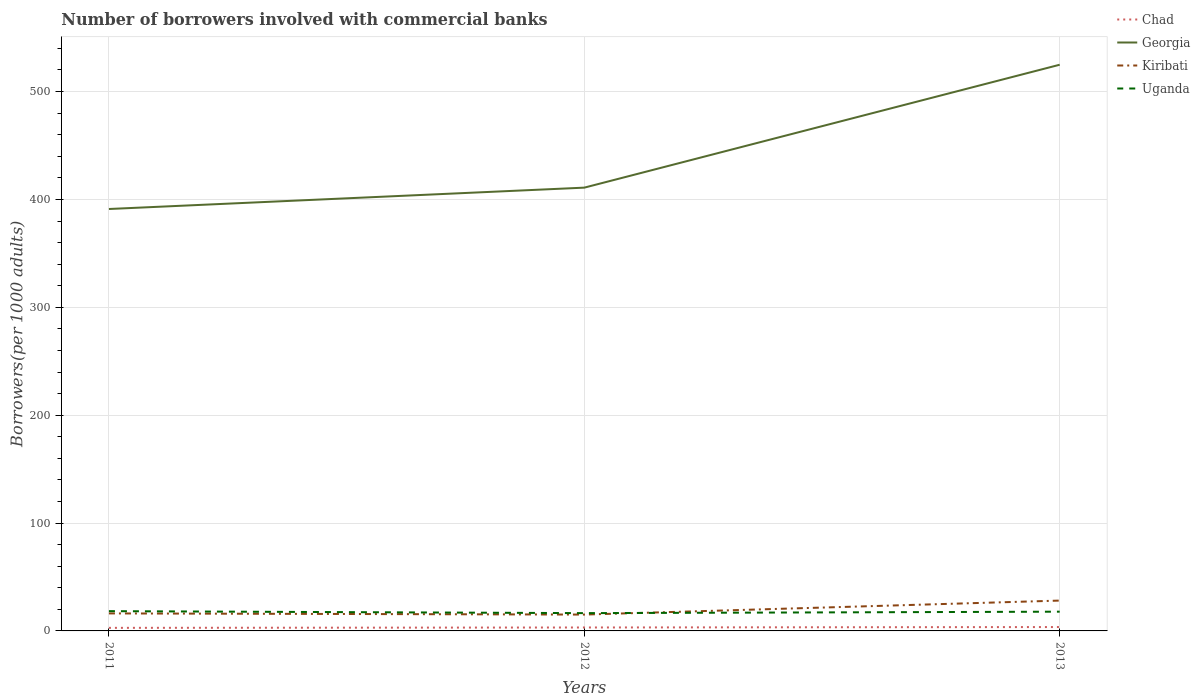Does the line corresponding to Uganda intersect with the line corresponding to Georgia?
Provide a succinct answer. No. Is the number of lines equal to the number of legend labels?
Your answer should be very brief. Yes. Across all years, what is the maximum number of borrowers involved with commercial banks in Uganda?
Keep it short and to the point. 16.49. What is the total number of borrowers involved with commercial banks in Georgia in the graph?
Offer a very short reply. -133.74. What is the difference between the highest and the second highest number of borrowers involved with commercial banks in Kiribati?
Ensure brevity in your answer.  12.98. How many lines are there?
Ensure brevity in your answer.  4. Are the values on the major ticks of Y-axis written in scientific E-notation?
Provide a short and direct response. No. Does the graph contain grids?
Keep it short and to the point. Yes. How many legend labels are there?
Your answer should be very brief. 4. How are the legend labels stacked?
Your response must be concise. Vertical. What is the title of the graph?
Make the answer very short. Number of borrowers involved with commercial banks. Does "Russian Federation" appear as one of the legend labels in the graph?
Your response must be concise. No. What is the label or title of the X-axis?
Provide a succinct answer. Years. What is the label or title of the Y-axis?
Your answer should be compact. Borrowers(per 1000 adults). What is the Borrowers(per 1000 adults) of Chad in 2011?
Your answer should be compact. 2.84. What is the Borrowers(per 1000 adults) in Georgia in 2011?
Make the answer very short. 391.13. What is the Borrowers(per 1000 adults) of Kiribati in 2011?
Provide a short and direct response. 16.23. What is the Borrowers(per 1000 adults) in Uganda in 2011?
Your answer should be compact. 18.33. What is the Borrowers(per 1000 adults) of Chad in 2012?
Provide a succinct answer. 3.18. What is the Borrowers(per 1000 adults) in Georgia in 2012?
Keep it short and to the point. 410.92. What is the Borrowers(per 1000 adults) in Kiribati in 2012?
Give a very brief answer. 15.15. What is the Borrowers(per 1000 adults) of Uganda in 2012?
Provide a succinct answer. 16.49. What is the Borrowers(per 1000 adults) in Chad in 2013?
Ensure brevity in your answer.  3.59. What is the Borrowers(per 1000 adults) of Georgia in 2013?
Offer a very short reply. 524.86. What is the Borrowers(per 1000 adults) in Kiribati in 2013?
Provide a short and direct response. 28.13. What is the Borrowers(per 1000 adults) in Uganda in 2013?
Offer a terse response. 17.84. Across all years, what is the maximum Borrowers(per 1000 adults) of Chad?
Provide a succinct answer. 3.59. Across all years, what is the maximum Borrowers(per 1000 adults) of Georgia?
Your answer should be compact. 524.86. Across all years, what is the maximum Borrowers(per 1000 adults) of Kiribati?
Give a very brief answer. 28.13. Across all years, what is the maximum Borrowers(per 1000 adults) in Uganda?
Provide a succinct answer. 18.33. Across all years, what is the minimum Borrowers(per 1000 adults) of Chad?
Give a very brief answer. 2.84. Across all years, what is the minimum Borrowers(per 1000 adults) of Georgia?
Ensure brevity in your answer.  391.13. Across all years, what is the minimum Borrowers(per 1000 adults) in Kiribati?
Provide a succinct answer. 15.15. Across all years, what is the minimum Borrowers(per 1000 adults) in Uganda?
Offer a terse response. 16.49. What is the total Borrowers(per 1000 adults) in Chad in the graph?
Provide a succinct answer. 9.61. What is the total Borrowers(per 1000 adults) in Georgia in the graph?
Your response must be concise. 1326.91. What is the total Borrowers(per 1000 adults) in Kiribati in the graph?
Keep it short and to the point. 59.51. What is the total Borrowers(per 1000 adults) of Uganda in the graph?
Your response must be concise. 52.67. What is the difference between the Borrowers(per 1000 adults) of Chad in 2011 and that in 2012?
Your response must be concise. -0.34. What is the difference between the Borrowers(per 1000 adults) in Georgia in 2011 and that in 2012?
Your answer should be compact. -19.79. What is the difference between the Borrowers(per 1000 adults) of Kiribati in 2011 and that in 2012?
Give a very brief answer. 1.08. What is the difference between the Borrowers(per 1000 adults) of Uganda in 2011 and that in 2012?
Your answer should be compact. 1.84. What is the difference between the Borrowers(per 1000 adults) of Chad in 2011 and that in 2013?
Offer a very short reply. -0.75. What is the difference between the Borrowers(per 1000 adults) of Georgia in 2011 and that in 2013?
Keep it short and to the point. -133.74. What is the difference between the Borrowers(per 1000 adults) of Kiribati in 2011 and that in 2013?
Keep it short and to the point. -11.9. What is the difference between the Borrowers(per 1000 adults) in Uganda in 2011 and that in 2013?
Keep it short and to the point. 0.49. What is the difference between the Borrowers(per 1000 adults) in Chad in 2012 and that in 2013?
Your answer should be very brief. -0.41. What is the difference between the Borrowers(per 1000 adults) of Georgia in 2012 and that in 2013?
Offer a terse response. -113.94. What is the difference between the Borrowers(per 1000 adults) of Kiribati in 2012 and that in 2013?
Provide a succinct answer. -12.98. What is the difference between the Borrowers(per 1000 adults) in Uganda in 2012 and that in 2013?
Provide a succinct answer. -1.35. What is the difference between the Borrowers(per 1000 adults) of Chad in 2011 and the Borrowers(per 1000 adults) of Georgia in 2012?
Give a very brief answer. -408.08. What is the difference between the Borrowers(per 1000 adults) in Chad in 2011 and the Borrowers(per 1000 adults) in Kiribati in 2012?
Your answer should be compact. -12.31. What is the difference between the Borrowers(per 1000 adults) of Chad in 2011 and the Borrowers(per 1000 adults) of Uganda in 2012?
Give a very brief answer. -13.65. What is the difference between the Borrowers(per 1000 adults) of Georgia in 2011 and the Borrowers(per 1000 adults) of Kiribati in 2012?
Ensure brevity in your answer.  375.97. What is the difference between the Borrowers(per 1000 adults) of Georgia in 2011 and the Borrowers(per 1000 adults) of Uganda in 2012?
Your answer should be compact. 374.64. What is the difference between the Borrowers(per 1000 adults) of Kiribati in 2011 and the Borrowers(per 1000 adults) of Uganda in 2012?
Give a very brief answer. -0.26. What is the difference between the Borrowers(per 1000 adults) in Chad in 2011 and the Borrowers(per 1000 adults) in Georgia in 2013?
Offer a very short reply. -522.02. What is the difference between the Borrowers(per 1000 adults) of Chad in 2011 and the Borrowers(per 1000 adults) of Kiribati in 2013?
Your answer should be very brief. -25.29. What is the difference between the Borrowers(per 1000 adults) of Chad in 2011 and the Borrowers(per 1000 adults) of Uganda in 2013?
Provide a short and direct response. -15. What is the difference between the Borrowers(per 1000 adults) in Georgia in 2011 and the Borrowers(per 1000 adults) in Kiribati in 2013?
Your response must be concise. 363. What is the difference between the Borrowers(per 1000 adults) in Georgia in 2011 and the Borrowers(per 1000 adults) in Uganda in 2013?
Your answer should be very brief. 373.29. What is the difference between the Borrowers(per 1000 adults) of Kiribati in 2011 and the Borrowers(per 1000 adults) of Uganda in 2013?
Your answer should be very brief. -1.61. What is the difference between the Borrowers(per 1000 adults) of Chad in 2012 and the Borrowers(per 1000 adults) of Georgia in 2013?
Provide a succinct answer. -521.69. What is the difference between the Borrowers(per 1000 adults) of Chad in 2012 and the Borrowers(per 1000 adults) of Kiribati in 2013?
Your answer should be compact. -24.95. What is the difference between the Borrowers(per 1000 adults) in Chad in 2012 and the Borrowers(per 1000 adults) in Uganda in 2013?
Keep it short and to the point. -14.66. What is the difference between the Borrowers(per 1000 adults) in Georgia in 2012 and the Borrowers(per 1000 adults) in Kiribati in 2013?
Offer a very short reply. 382.79. What is the difference between the Borrowers(per 1000 adults) of Georgia in 2012 and the Borrowers(per 1000 adults) of Uganda in 2013?
Your answer should be very brief. 393.08. What is the difference between the Borrowers(per 1000 adults) of Kiribati in 2012 and the Borrowers(per 1000 adults) of Uganda in 2013?
Provide a short and direct response. -2.69. What is the average Borrowers(per 1000 adults) in Chad per year?
Give a very brief answer. 3.2. What is the average Borrowers(per 1000 adults) in Georgia per year?
Offer a terse response. 442.3. What is the average Borrowers(per 1000 adults) in Kiribati per year?
Your response must be concise. 19.84. What is the average Borrowers(per 1000 adults) in Uganda per year?
Make the answer very short. 17.56. In the year 2011, what is the difference between the Borrowers(per 1000 adults) of Chad and Borrowers(per 1000 adults) of Georgia?
Make the answer very short. -388.28. In the year 2011, what is the difference between the Borrowers(per 1000 adults) of Chad and Borrowers(per 1000 adults) of Kiribati?
Keep it short and to the point. -13.39. In the year 2011, what is the difference between the Borrowers(per 1000 adults) in Chad and Borrowers(per 1000 adults) in Uganda?
Your answer should be compact. -15.49. In the year 2011, what is the difference between the Borrowers(per 1000 adults) of Georgia and Borrowers(per 1000 adults) of Kiribati?
Keep it short and to the point. 374.9. In the year 2011, what is the difference between the Borrowers(per 1000 adults) in Georgia and Borrowers(per 1000 adults) in Uganda?
Ensure brevity in your answer.  372.8. In the year 2011, what is the difference between the Borrowers(per 1000 adults) of Kiribati and Borrowers(per 1000 adults) of Uganda?
Your answer should be compact. -2.1. In the year 2012, what is the difference between the Borrowers(per 1000 adults) in Chad and Borrowers(per 1000 adults) in Georgia?
Keep it short and to the point. -407.74. In the year 2012, what is the difference between the Borrowers(per 1000 adults) of Chad and Borrowers(per 1000 adults) of Kiribati?
Your answer should be very brief. -11.97. In the year 2012, what is the difference between the Borrowers(per 1000 adults) in Chad and Borrowers(per 1000 adults) in Uganda?
Your answer should be very brief. -13.31. In the year 2012, what is the difference between the Borrowers(per 1000 adults) of Georgia and Borrowers(per 1000 adults) of Kiribati?
Ensure brevity in your answer.  395.77. In the year 2012, what is the difference between the Borrowers(per 1000 adults) in Georgia and Borrowers(per 1000 adults) in Uganda?
Offer a very short reply. 394.43. In the year 2012, what is the difference between the Borrowers(per 1000 adults) of Kiribati and Borrowers(per 1000 adults) of Uganda?
Offer a very short reply. -1.34. In the year 2013, what is the difference between the Borrowers(per 1000 adults) in Chad and Borrowers(per 1000 adults) in Georgia?
Make the answer very short. -521.27. In the year 2013, what is the difference between the Borrowers(per 1000 adults) of Chad and Borrowers(per 1000 adults) of Kiribati?
Keep it short and to the point. -24.54. In the year 2013, what is the difference between the Borrowers(per 1000 adults) of Chad and Borrowers(per 1000 adults) of Uganda?
Make the answer very short. -14.25. In the year 2013, what is the difference between the Borrowers(per 1000 adults) in Georgia and Borrowers(per 1000 adults) in Kiribati?
Your answer should be very brief. 496.74. In the year 2013, what is the difference between the Borrowers(per 1000 adults) in Georgia and Borrowers(per 1000 adults) in Uganda?
Ensure brevity in your answer.  507.02. In the year 2013, what is the difference between the Borrowers(per 1000 adults) of Kiribati and Borrowers(per 1000 adults) of Uganda?
Your response must be concise. 10.29. What is the ratio of the Borrowers(per 1000 adults) in Chad in 2011 to that in 2012?
Your answer should be compact. 0.89. What is the ratio of the Borrowers(per 1000 adults) in Georgia in 2011 to that in 2012?
Your response must be concise. 0.95. What is the ratio of the Borrowers(per 1000 adults) of Kiribati in 2011 to that in 2012?
Ensure brevity in your answer.  1.07. What is the ratio of the Borrowers(per 1000 adults) in Uganda in 2011 to that in 2012?
Provide a succinct answer. 1.11. What is the ratio of the Borrowers(per 1000 adults) of Chad in 2011 to that in 2013?
Provide a succinct answer. 0.79. What is the ratio of the Borrowers(per 1000 adults) in Georgia in 2011 to that in 2013?
Your answer should be compact. 0.75. What is the ratio of the Borrowers(per 1000 adults) in Kiribati in 2011 to that in 2013?
Your answer should be compact. 0.58. What is the ratio of the Borrowers(per 1000 adults) of Uganda in 2011 to that in 2013?
Your answer should be compact. 1.03. What is the ratio of the Borrowers(per 1000 adults) in Chad in 2012 to that in 2013?
Your answer should be very brief. 0.89. What is the ratio of the Borrowers(per 1000 adults) of Georgia in 2012 to that in 2013?
Give a very brief answer. 0.78. What is the ratio of the Borrowers(per 1000 adults) in Kiribati in 2012 to that in 2013?
Ensure brevity in your answer.  0.54. What is the ratio of the Borrowers(per 1000 adults) in Uganda in 2012 to that in 2013?
Your answer should be compact. 0.92. What is the difference between the highest and the second highest Borrowers(per 1000 adults) of Chad?
Offer a terse response. 0.41. What is the difference between the highest and the second highest Borrowers(per 1000 adults) in Georgia?
Your response must be concise. 113.94. What is the difference between the highest and the second highest Borrowers(per 1000 adults) in Kiribati?
Provide a succinct answer. 11.9. What is the difference between the highest and the second highest Borrowers(per 1000 adults) in Uganda?
Keep it short and to the point. 0.49. What is the difference between the highest and the lowest Borrowers(per 1000 adults) in Chad?
Your answer should be compact. 0.75. What is the difference between the highest and the lowest Borrowers(per 1000 adults) of Georgia?
Provide a short and direct response. 133.74. What is the difference between the highest and the lowest Borrowers(per 1000 adults) in Kiribati?
Ensure brevity in your answer.  12.98. What is the difference between the highest and the lowest Borrowers(per 1000 adults) in Uganda?
Your answer should be compact. 1.84. 